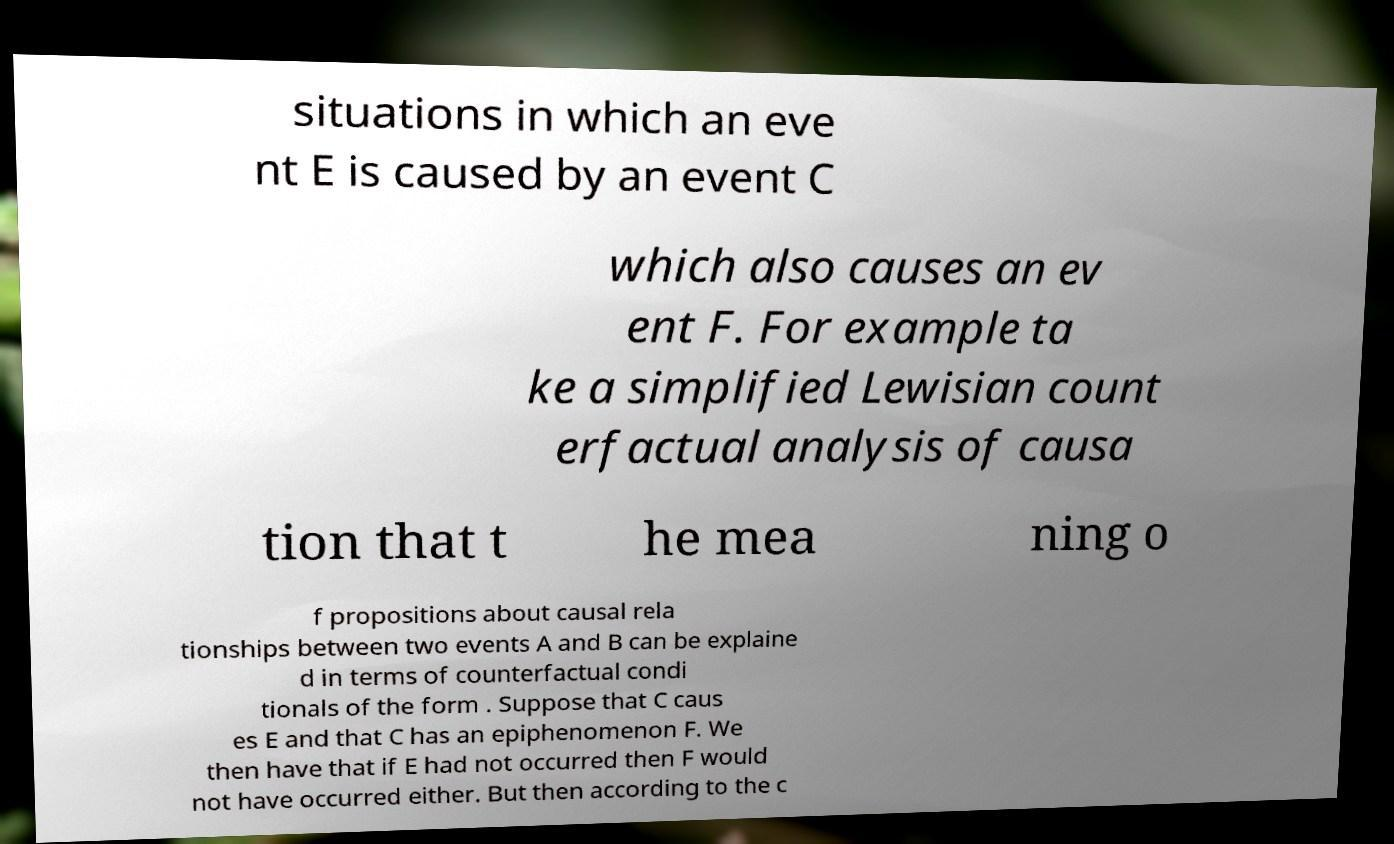Please identify and transcribe the text found in this image. situations in which an eve nt E is caused by an event C which also causes an ev ent F. For example ta ke a simplified Lewisian count erfactual analysis of causa tion that t he mea ning o f propositions about causal rela tionships between two events A and B can be explaine d in terms of counterfactual condi tionals of the form . Suppose that C caus es E and that C has an epiphenomenon F. We then have that if E had not occurred then F would not have occurred either. But then according to the c 